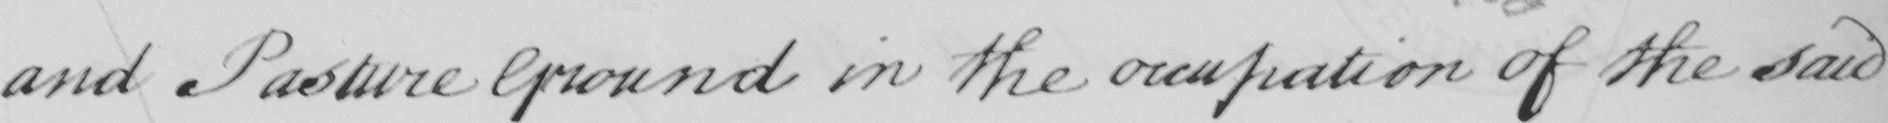What text is written in this handwritten line? and Pasture Ground in the occupation of the said 